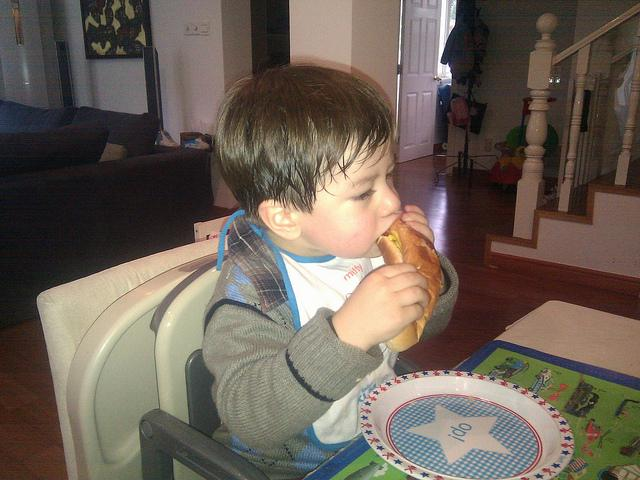What color is the plaid pattern around the star on top of the plate?

Choices:
A) blue
B) green
C) red
D) purple blue 